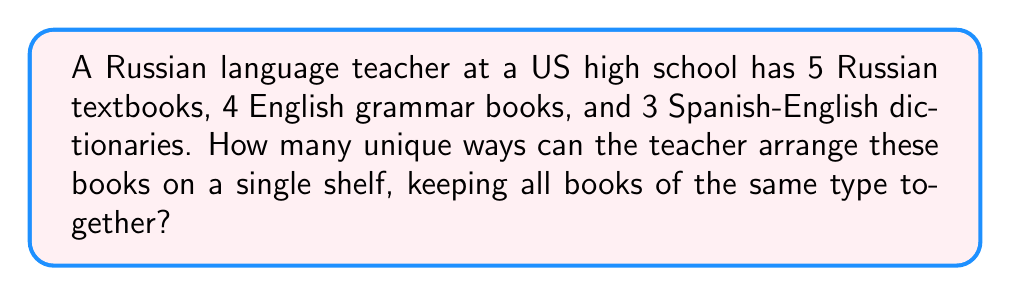Show me your answer to this math problem. Let's approach this step-by-step:

1) First, we need to consider the books of each type as a single unit. So we have 3 units to arrange: Russian textbooks, English grammar books, and Spanish-English dictionaries.

2) The number of ways to arrange these 3 units is simply 3! (3 factorial):

   $$3! = 3 \times 2 \times 1 = 6$$

3) Now, for each of these 6 arrangements, we need to consider the ways to arrange the books within each type:

   - For the 5 Russian textbooks: 5!
   - For the 4 English grammar books: 4!
   - For the 3 Spanish-English dictionaries: 3!

4) According to the Multiplication Principle, we multiply all these possibilities:

   $$6 \times 5! \times 4! \times 3!$$

5) Let's calculate this:
   
   $$6 \times (5 \times 4 \times 3 \times 2 \times 1) \times (4 \times 3 \times 2 \times 1) \times (3 \times 2 \times 1)$$
   
   $$= 6 \times 120 \times 24 \times 6$$
   
   $$= 103,680$$

Therefore, there are 103,680 unique ways to arrange the books.
Answer: 103,680 